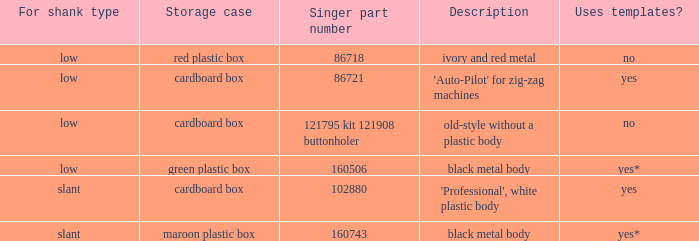What's the description of the buttonholer whose singer part number is 121795 kit 121908 buttonholer? Old-style without a plastic body. 